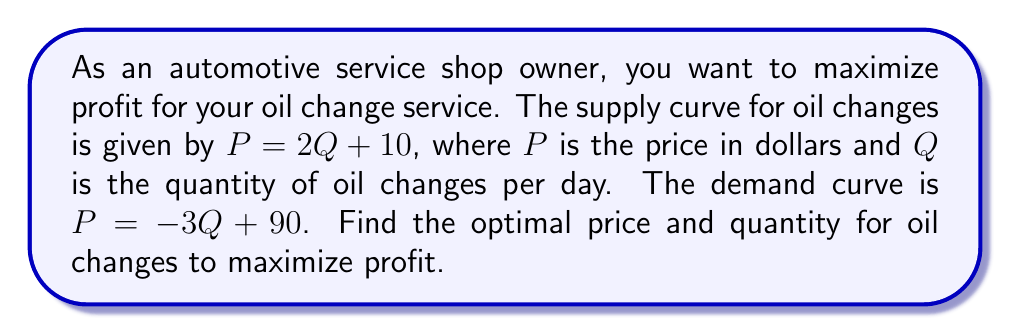Give your solution to this math problem. 1. To find the optimal price and quantity, we need to find the equilibrium point where supply equals demand:

   $2Q + 10 = -3Q + 90$

2. Solve for Q:
   $5Q = 80$
   $Q = 16$

3. Substitute Q = 16 into either the supply or demand equation to find P:
   $P = 2(16) + 10 = 42$
   or
   $P = -3(16) + 90 = 42$

4. The equilibrium point is (16, 42), meaning 16 oil changes per day at $42 each.

5. To verify this maximizes profit, we can calculate the profit function:
   $\text{Profit} = \text{Revenue} - \text{Cost}$
   $\pi = PQ - (10Q + 5Q^2/2)$

6. Substitute P from the demand curve:
   $\pi = (-3Q + 90)Q - (10Q + 5Q^2/2)$
   $\pi = -3Q^2 + 90Q - 10Q - 5Q^2/2$
   $\pi = -3Q^2 + 80Q - 5Q^2/2$
   $\pi = -11Q^2/2 + 80Q$

7. To maximize profit, find where $\frac{d\pi}{dQ} = 0$:
   $\frac{d\pi}{dQ} = -11Q + 80 = 0$
   $11Q = 80$
   $Q = 16$

This confirms that 16 oil changes per day at $42 each maximizes profit.
Answer: 16 oil changes per day at $42 each 